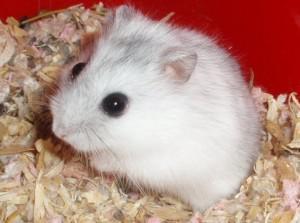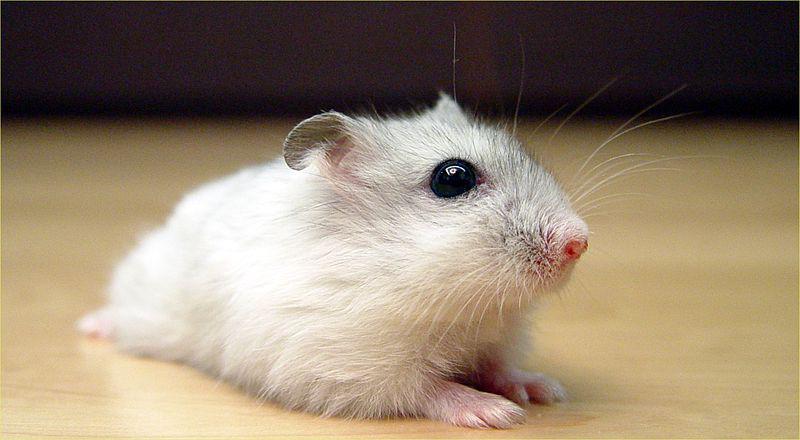The first image is the image on the left, the second image is the image on the right. Assess this claim about the two images: "A rodent is lying across a flat glossy surface in one of the images.". Correct or not? Answer yes or no. Yes. The first image is the image on the left, the second image is the image on the right. Considering the images on both sides, is "An image shows one rodent pet lying with its belly flat on a light-colored wood surface." valid? Answer yes or no. Yes. 